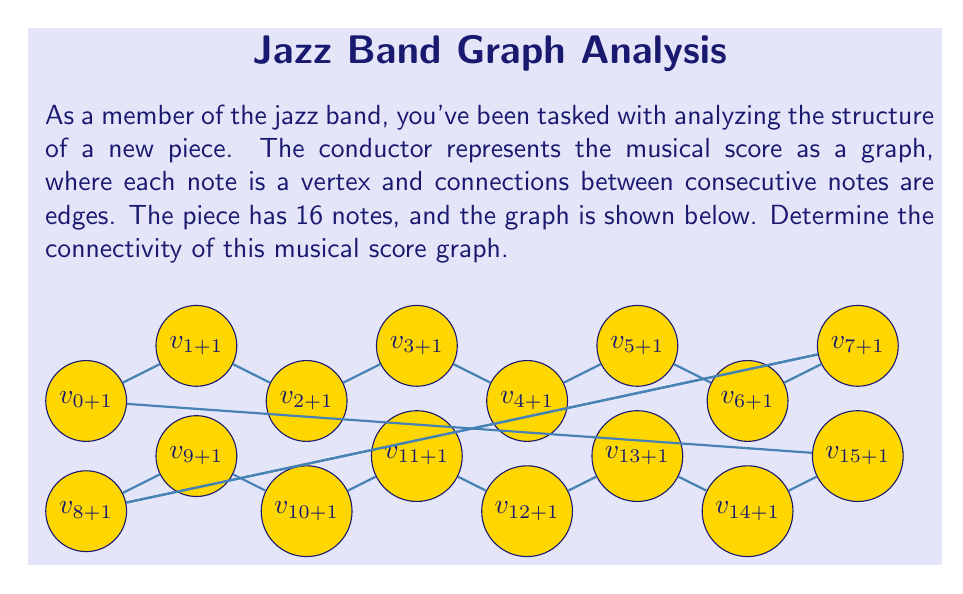Can you answer this question? To determine the connectivity of this graph, we need to find the minimum number of vertices that need to be removed to disconnect the graph. Let's approach this step-by-step:

1) First, observe that the graph forms a cycle. This means it's 2-edge-connected, but we need to determine its vertex connectivity.

2) Notice that removing any single vertex will not disconnect the graph. There's always an alternate path between any two remaining vertices.

3) However, if we remove two non-adjacent vertices, we can disconnect the graph. For example:
   - If we remove $v_1$ and $v_9$, the graph splits into two disconnected paths.
   - The same happens if we remove $v_5$ and $v_{13}$, or any other pair of vertices that are separated by 7 positions in the cycle.

4) We can't disconnect the graph by removing fewer than 2 vertices, and we've shown that 2 vertices are sufficient.

5) Therefore, the vertex connectivity of this graph is 2.

In graph theory, this type of graph is known as a cycle graph or circular graph, denoted as $C_{16}$ (since it has 16 vertices). Cycle graphs always have a connectivity of 2, except for $C_3$ which has a connectivity of 3.

This connectivity indicates that the musical piece has a cyclic structure, where each note is connected to two others, forming a continuous loop. This could represent a repeating musical phrase or a round in jazz composition.
Answer: 2 